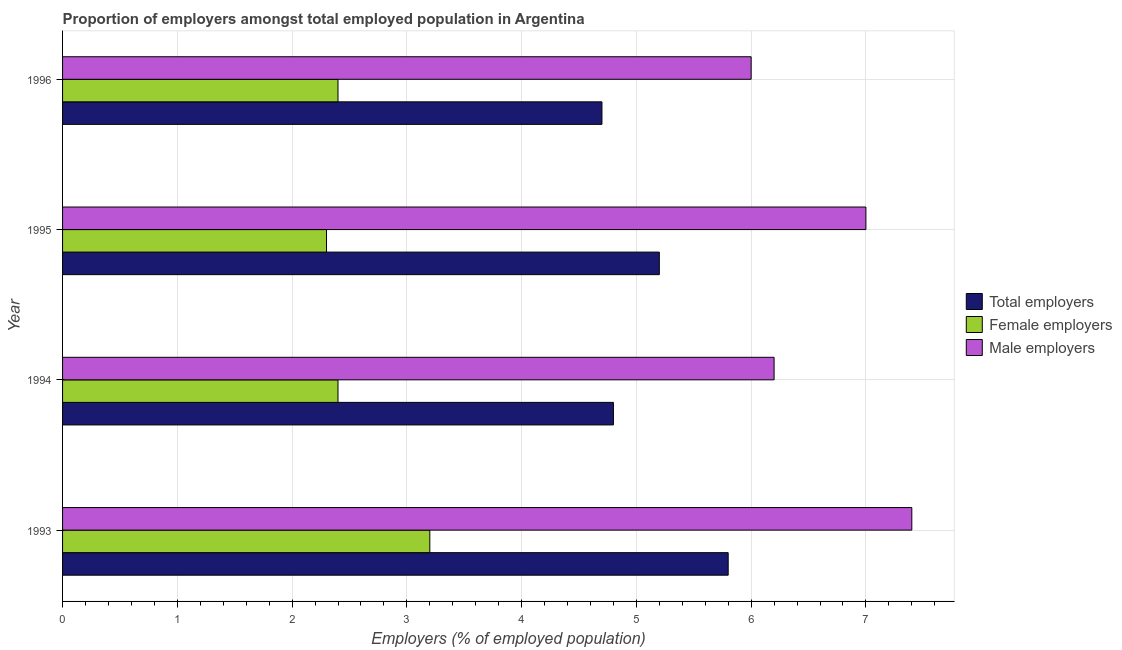How many different coloured bars are there?
Offer a very short reply. 3. Are the number of bars on each tick of the Y-axis equal?
Your response must be concise. Yes. In how many cases, is the number of bars for a given year not equal to the number of legend labels?
Your answer should be compact. 0. What is the percentage of total employers in 1995?
Ensure brevity in your answer.  5.2. Across all years, what is the maximum percentage of female employers?
Make the answer very short. 3.2. Across all years, what is the minimum percentage of total employers?
Your answer should be very brief. 4.7. In which year was the percentage of total employers maximum?
Keep it short and to the point. 1993. In which year was the percentage of male employers minimum?
Offer a very short reply. 1996. What is the total percentage of female employers in the graph?
Ensure brevity in your answer.  10.3. What is the difference between the percentage of male employers in 1994 and that in 1996?
Ensure brevity in your answer.  0.2. What is the difference between the percentage of male employers in 1995 and the percentage of total employers in 1996?
Provide a short and direct response. 2.3. What is the average percentage of male employers per year?
Your answer should be compact. 6.65. In the year 1994, what is the difference between the percentage of female employers and percentage of male employers?
Give a very brief answer. -3.8. In how many years, is the percentage of female employers greater than 7 %?
Your response must be concise. 0. What is the ratio of the percentage of male employers in 1993 to that in 1996?
Provide a succinct answer. 1.23. Is the percentage of female employers in 1995 less than that in 1996?
Provide a short and direct response. Yes. In how many years, is the percentage of male employers greater than the average percentage of male employers taken over all years?
Keep it short and to the point. 2. What does the 2nd bar from the top in 1996 represents?
Ensure brevity in your answer.  Female employers. What does the 3rd bar from the bottom in 1995 represents?
Give a very brief answer. Male employers. How many bars are there?
Offer a terse response. 12. Are all the bars in the graph horizontal?
Give a very brief answer. Yes. How many years are there in the graph?
Ensure brevity in your answer.  4. What is the difference between two consecutive major ticks on the X-axis?
Ensure brevity in your answer.  1. Are the values on the major ticks of X-axis written in scientific E-notation?
Offer a terse response. No. Where does the legend appear in the graph?
Provide a short and direct response. Center right. What is the title of the graph?
Give a very brief answer. Proportion of employers amongst total employed population in Argentina. Does "Ages 60+" appear as one of the legend labels in the graph?
Your answer should be very brief. No. What is the label or title of the X-axis?
Make the answer very short. Employers (% of employed population). What is the label or title of the Y-axis?
Give a very brief answer. Year. What is the Employers (% of employed population) in Total employers in 1993?
Your answer should be very brief. 5.8. What is the Employers (% of employed population) of Female employers in 1993?
Provide a short and direct response. 3.2. What is the Employers (% of employed population) of Male employers in 1993?
Your answer should be compact. 7.4. What is the Employers (% of employed population) in Total employers in 1994?
Provide a short and direct response. 4.8. What is the Employers (% of employed population) of Female employers in 1994?
Your response must be concise. 2.4. What is the Employers (% of employed population) in Male employers in 1994?
Offer a very short reply. 6.2. What is the Employers (% of employed population) in Total employers in 1995?
Provide a short and direct response. 5.2. What is the Employers (% of employed population) in Female employers in 1995?
Give a very brief answer. 2.3. What is the Employers (% of employed population) in Male employers in 1995?
Offer a very short reply. 7. What is the Employers (% of employed population) in Total employers in 1996?
Provide a succinct answer. 4.7. What is the Employers (% of employed population) of Female employers in 1996?
Your response must be concise. 2.4. What is the Employers (% of employed population) in Male employers in 1996?
Your response must be concise. 6. Across all years, what is the maximum Employers (% of employed population) in Total employers?
Offer a very short reply. 5.8. Across all years, what is the maximum Employers (% of employed population) in Female employers?
Give a very brief answer. 3.2. Across all years, what is the maximum Employers (% of employed population) in Male employers?
Provide a short and direct response. 7.4. Across all years, what is the minimum Employers (% of employed population) of Total employers?
Your answer should be compact. 4.7. Across all years, what is the minimum Employers (% of employed population) of Female employers?
Offer a very short reply. 2.3. What is the total Employers (% of employed population) of Female employers in the graph?
Your response must be concise. 10.3. What is the total Employers (% of employed population) of Male employers in the graph?
Give a very brief answer. 26.6. What is the difference between the Employers (% of employed population) of Female employers in 1993 and that in 1994?
Your response must be concise. 0.8. What is the difference between the Employers (% of employed population) in Male employers in 1993 and that in 1994?
Give a very brief answer. 1.2. What is the difference between the Employers (% of employed population) in Female employers in 1993 and that in 1996?
Offer a very short reply. 0.8. What is the difference between the Employers (% of employed population) of Total employers in 1994 and that in 1995?
Offer a very short reply. -0.4. What is the difference between the Employers (% of employed population) in Total employers in 1994 and that in 1996?
Ensure brevity in your answer.  0.1. What is the difference between the Employers (% of employed population) of Male employers in 1994 and that in 1996?
Offer a very short reply. 0.2. What is the difference between the Employers (% of employed population) in Male employers in 1995 and that in 1996?
Keep it short and to the point. 1. What is the difference between the Employers (% of employed population) of Total employers in 1993 and the Employers (% of employed population) of Female employers in 1994?
Your answer should be very brief. 3.4. What is the difference between the Employers (% of employed population) of Female employers in 1993 and the Employers (% of employed population) of Male employers in 1994?
Provide a short and direct response. -3. What is the difference between the Employers (% of employed population) of Total employers in 1993 and the Employers (% of employed population) of Female employers in 1995?
Your response must be concise. 3.5. What is the difference between the Employers (% of employed population) in Total employers in 1993 and the Employers (% of employed population) in Female employers in 1996?
Keep it short and to the point. 3.4. What is the difference between the Employers (% of employed population) of Female employers in 1993 and the Employers (% of employed population) of Male employers in 1996?
Your answer should be very brief. -2.8. What is the difference between the Employers (% of employed population) of Total employers in 1994 and the Employers (% of employed population) of Male employers in 1995?
Your answer should be compact. -2.2. What is the difference between the Employers (% of employed population) of Female employers in 1994 and the Employers (% of employed population) of Male employers in 1995?
Your answer should be very brief. -4.6. What is the difference between the Employers (% of employed population) in Total employers in 1994 and the Employers (% of employed population) in Male employers in 1996?
Your answer should be compact. -1.2. What is the difference between the Employers (% of employed population) in Total employers in 1995 and the Employers (% of employed population) in Male employers in 1996?
Offer a terse response. -0.8. What is the average Employers (% of employed population) of Total employers per year?
Offer a very short reply. 5.12. What is the average Employers (% of employed population) in Female employers per year?
Give a very brief answer. 2.58. What is the average Employers (% of employed population) of Male employers per year?
Offer a very short reply. 6.65. In the year 1993, what is the difference between the Employers (% of employed population) of Total employers and Employers (% of employed population) of Female employers?
Make the answer very short. 2.6. In the year 1993, what is the difference between the Employers (% of employed population) in Female employers and Employers (% of employed population) in Male employers?
Offer a very short reply. -4.2. In the year 1994, what is the difference between the Employers (% of employed population) in Total employers and Employers (% of employed population) in Female employers?
Offer a terse response. 2.4. In the year 1994, what is the difference between the Employers (% of employed population) of Total employers and Employers (% of employed population) of Male employers?
Ensure brevity in your answer.  -1.4. In the year 1994, what is the difference between the Employers (% of employed population) in Female employers and Employers (% of employed population) in Male employers?
Provide a short and direct response. -3.8. In the year 1995, what is the difference between the Employers (% of employed population) in Total employers and Employers (% of employed population) in Female employers?
Ensure brevity in your answer.  2.9. In the year 1995, what is the difference between the Employers (% of employed population) in Total employers and Employers (% of employed population) in Male employers?
Provide a short and direct response. -1.8. In the year 1996, what is the difference between the Employers (% of employed population) of Total employers and Employers (% of employed population) of Female employers?
Provide a succinct answer. 2.3. What is the ratio of the Employers (% of employed population) of Total employers in 1993 to that in 1994?
Offer a terse response. 1.21. What is the ratio of the Employers (% of employed population) in Male employers in 1993 to that in 1994?
Your answer should be very brief. 1.19. What is the ratio of the Employers (% of employed population) of Total employers in 1993 to that in 1995?
Offer a terse response. 1.12. What is the ratio of the Employers (% of employed population) of Female employers in 1993 to that in 1995?
Provide a succinct answer. 1.39. What is the ratio of the Employers (% of employed population) in Male employers in 1993 to that in 1995?
Provide a short and direct response. 1.06. What is the ratio of the Employers (% of employed population) of Total employers in 1993 to that in 1996?
Provide a succinct answer. 1.23. What is the ratio of the Employers (% of employed population) in Male employers in 1993 to that in 1996?
Ensure brevity in your answer.  1.23. What is the ratio of the Employers (% of employed population) of Total employers in 1994 to that in 1995?
Give a very brief answer. 0.92. What is the ratio of the Employers (% of employed population) of Female employers in 1994 to that in 1995?
Your response must be concise. 1.04. What is the ratio of the Employers (% of employed population) of Male employers in 1994 to that in 1995?
Give a very brief answer. 0.89. What is the ratio of the Employers (% of employed population) in Total employers in 1994 to that in 1996?
Offer a terse response. 1.02. What is the ratio of the Employers (% of employed population) in Female employers in 1994 to that in 1996?
Ensure brevity in your answer.  1. What is the ratio of the Employers (% of employed population) of Total employers in 1995 to that in 1996?
Ensure brevity in your answer.  1.11. What is the ratio of the Employers (% of employed population) in Female employers in 1995 to that in 1996?
Your answer should be very brief. 0.96. What is the ratio of the Employers (% of employed population) of Male employers in 1995 to that in 1996?
Your answer should be compact. 1.17. What is the difference between the highest and the second highest Employers (% of employed population) of Male employers?
Offer a very short reply. 0.4. What is the difference between the highest and the lowest Employers (% of employed population) of Total employers?
Keep it short and to the point. 1.1. What is the difference between the highest and the lowest Employers (% of employed population) of Female employers?
Offer a terse response. 0.9. What is the difference between the highest and the lowest Employers (% of employed population) of Male employers?
Ensure brevity in your answer.  1.4. 